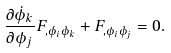<formula> <loc_0><loc_0><loc_500><loc_500>\frac { \partial \dot { \phi } _ { k } } { \partial \phi _ { j } } F _ { , \dot { \phi _ { i } } \dot { \phi } _ { k } } + F _ { , \phi _ { i } \dot { \phi } _ { j } } = 0 .</formula> 